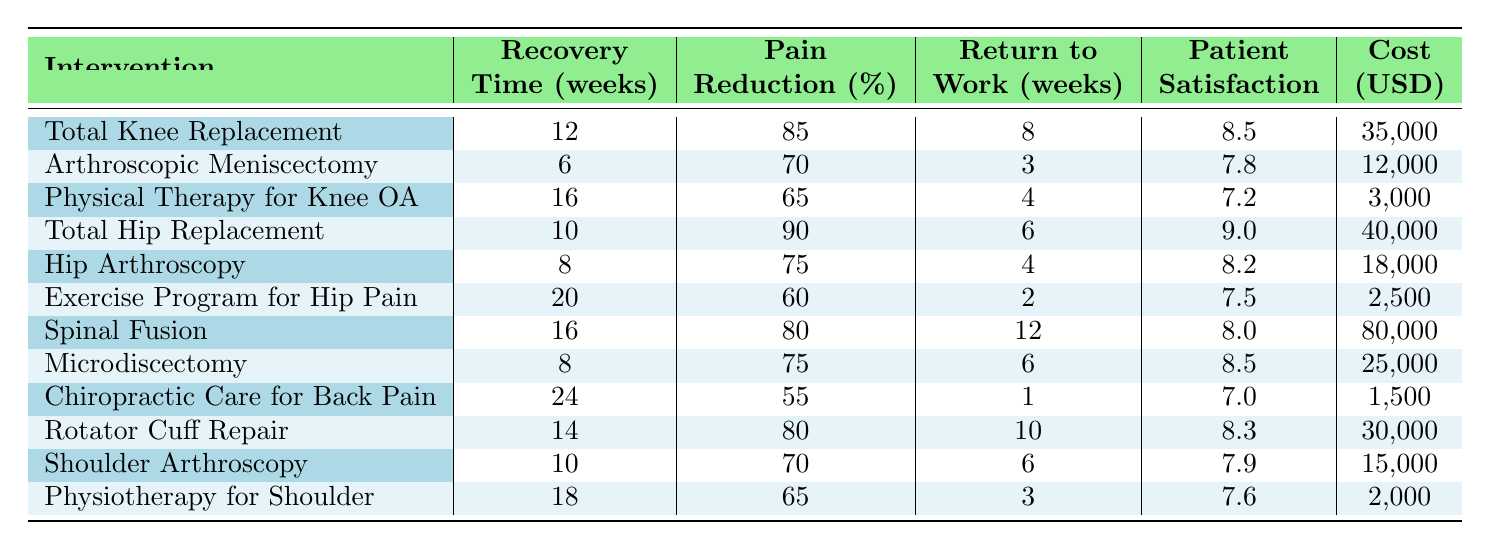What is the recovery time for Total Hip Replacement? The recovery time for Total Hip Replacement is directly stated in the table. It shows 10 weeks.
Answer: 10 weeks Which intervention has the highest patient satisfaction score? By comparing the patient satisfaction scores in the table, Total Hip Replacement has the highest score of 9.0.
Answer: Total Hip Replacement What is the average recovery time for surgical interventions? The surgical interventions are: Total Knee Replacement (12), Arthroscopic Meniscectomy (6), Total Hip Replacement (10), Spinal Fusion (16), Microdiscectomy (8), Rotator Cuff Repair (14), and Shoulder Arthroscopy (10). Adding these (12 + 6 + 10 + 16 + 8 + 14 + 10 = 76) gives 76 weeks. Since there are 7 surgical interventions, the average is 76/7 = approximately 10.86 weeks.
Answer: Approximately 10.86 weeks Is the pain reduction percentage greater for Hip Arthroscopy than for Arthroscopic Meniscectomy? The table shows Hip Arthroscopy has a pain reduction percentage of 75%, while Arthroscopic Meniscectomy has 70%. Since 75% is greater than 70%, the statement is true.
Answer: Yes What is the total cost of Physical Therapy for Knee Osteoarthritis and Chiropractic Care for Lower Back Pain? The cost of Physical Therapy for Knee Osteoarthritis is $3,000 and for Chiropractic Care for Lower Back Pain is $1,500. Adding these costs gives $3,000 + $1,500 = $4,500.
Answer: $4,500 How much longer does it take to recover from Spinal Fusion compared to Hip Arthroscopy? The recovery time for Spinal Fusion is 16 weeks and for Hip Arthroscopy, it is 8 weeks. The difference is 16 - 8 = 8 weeks longer for Spinal Fusion.
Answer: 8 weeks longer Which intervention has the lowest cost and what is that cost? The cost values are checked from the table. The lowest cost is for Chiropractic Care for Lower Back Pain at $1,500.
Answer: $1,500 Calculate the median return to work weeks for all interventions listed. The return to work weeks are: 8, 3, 4, 6, 4, 2, 12, 6, 1, 10, 6, 3. Arranging these values in ascending order (1, 2, 3, 3, 4, 4, 6, 6, 6, 8, 10, 12) gives 12 values. The median is the average of the 6th and 7th values: (4 + 6) / 2 = 5.
Answer: 5 weeks Does the Total Knee Replacement have a lower recovery time than Spinal Fusion? The Total Knee Replacement recovery time is 12 weeks, while Spinal Fusion is 16 weeks. Since 12 is less than 16, the statement is true.
Answer: Yes What is the difference between the highest and lowest patient satisfaction scores? The highest patient satisfaction score is 9.0 (Total Hip Replacement) and the lowest is 7.2 (Physical Therapy for Knee Osteoarthritis). The difference is 9.0 - 7.2 = 1.8.
Answer: 1.8 